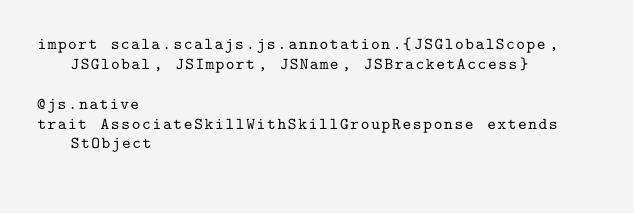<code> <loc_0><loc_0><loc_500><loc_500><_Scala_>import scala.scalajs.js.annotation.{JSGlobalScope, JSGlobal, JSImport, JSName, JSBracketAccess}

@js.native
trait AssociateSkillWithSkillGroupResponse extends StObject
</code> 